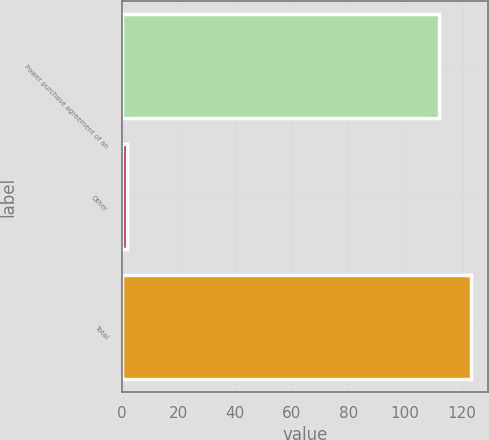<chart> <loc_0><loc_0><loc_500><loc_500><bar_chart><fcel>Power purchase agreement of an<fcel>Other<fcel>Total<nl><fcel>112<fcel>2<fcel>123.2<nl></chart> 